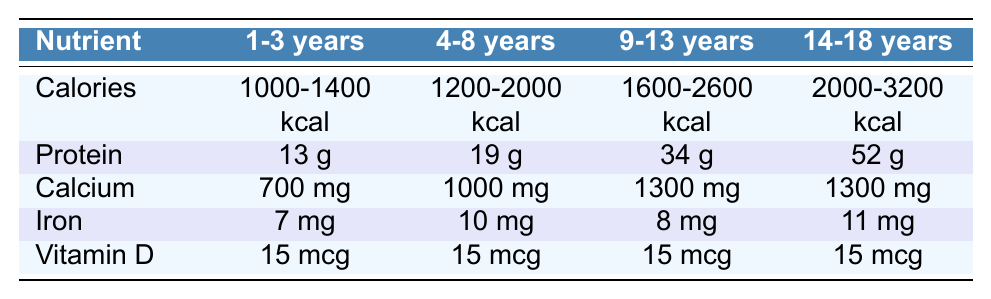What is the recommended daily intake of protein for children aged 1-3 years? The table lists the nutrients along with their recommended daily intakes for different age groups. For the 1-3 years age group, the recommended daily intake of protein is explicitly specified as 13 g.
Answer: 13 g What is the recommended daily intake of calcium for children aged 4-8 years? Referring to the table, we find that for the age group 4-8 years, the recommended daily intake of calcium is listed as 1000 mg.
Answer: 1000 mg How much more protein is required for adolescents aged 14-18 years compared to children aged 9-13 years? By looking at the table, the protein intake for 14-18 years is 52 g, while for 9-13 years it is 34 g. The difference is 52 g - 34 g = 18 g.
Answer: 18 g What is the range of recommended daily caloric intake for children aged 9-13 years? The table shows that for children aged 9-13 years, the range of recommended daily caloric intake is from 1600 to 2600 kcal.
Answer: 1600-2600 kcal Is the recommended daily intake of Vitamin D the same for all age groups listed? The table indicates that for all age groups, the recommended daily intake of Vitamin D is consistently 15 mcg. Therefore, the statement is true.
Answer: Yes What is the total recommended daily intake of iron for the age group 1-3 years compared to 4-8 years? The table shows that 1-3 years require 7 mg of iron and 4-8 years require 10 mg. Adding these together gives a total of 7 mg + 10 mg = 17 mg.
Answer: 17 mg For children aged 14-18 years, how does the caloric intake compare to that of the 1-3 year group? The caloric intake for 14-18 years is 2000-3200 kcal, and for 1-3 years it is 1000-1400 kcal. The minimum for 14-18 years is greater than the maximum for 1-3 years (2000 > 1400), indicating significantly higher requirements.
Answer: Higher What is the average recommended daily intake of calcium across all age groups? From the table, the calcium intakes for the age groups are 700 mg, 1000 mg, 1300 mg, and 1300 mg. Summing these gives 700 + 1000 + 1300 + 1300 = 4300 mg. Dividing by 4 (the number of groups) gives an average of 1075 mg.
Answer: 1075 mg Which age group has the highest requirement for protein? Looking at the protein values in the table, the highest intake is for the 14-18 years age group, with a requirement of 52 g, higher than the other groups.
Answer: 14-18 years What is the difference in the recommended daily intake of calories between the youngest and the oldest age groups? The 1-3 years age group requires 1000-1400 kcal, while the 14-18 years group requires 2000-3200 kcal. Taking the lower end, 2000 kcal - 1400 kcal = 600 kcal. Taking the upper end, 3200 kcal - 1000 kcal = 2200 kcal. Therefore, the difference in the ranges can be stated as up to 2200 kcal.
Answer: 600-2200 kcal 